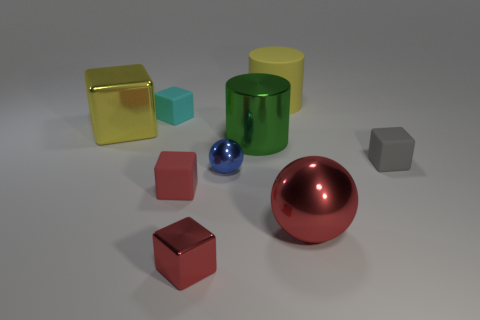Subtract all tiny gray cubes. How many cubes are left? 4 Subtract all gray cubes. How many cubes are left? 4 Subtract 2 blocks. How many blocks are left? 3 Subtract all cyan cubes. Subtract all red cylinders. How many cubes are left? 4 Add 1 tiny red cubes. How many objects exist? 10 Subtract all cubes. How many objects are left? 4 Add 5 gray matte cubes. How many gray matte cubes exist? 6 Subtract 0 cyan cylinders. How many objects are left? 9 Subtract all small objects. Subtract all green matte things. How many objects are left? 4 Add 3 yellow blocks. How many yellow blocks are left? 4 